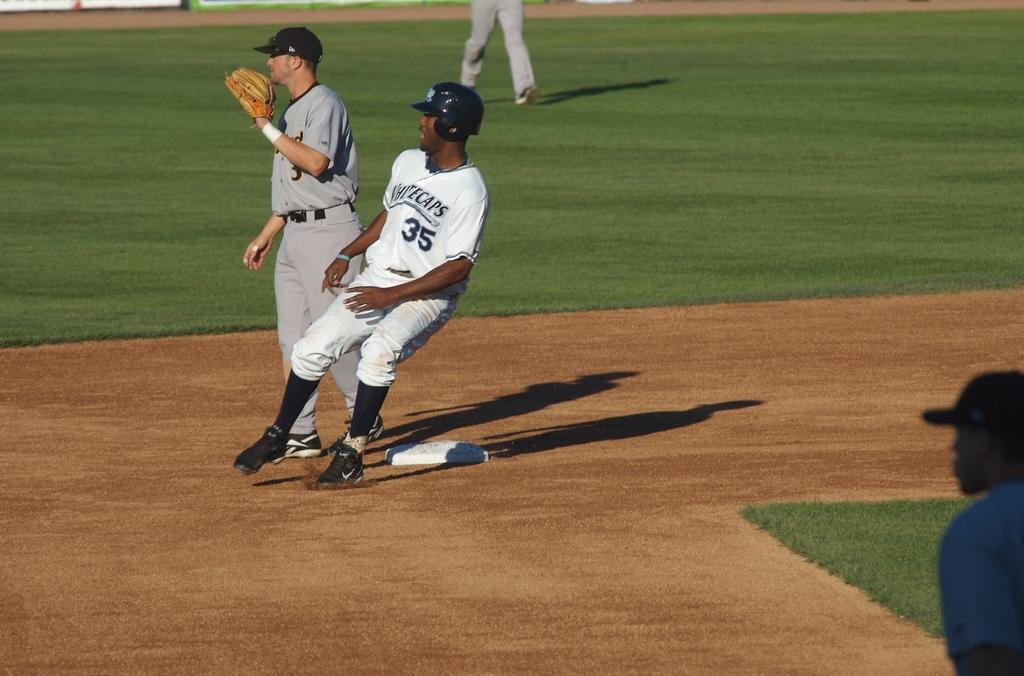What is the number of the runner?
Ensure brevity in your answer.  35. What team is he on?
Give a very brief answer. Whitecaps. 